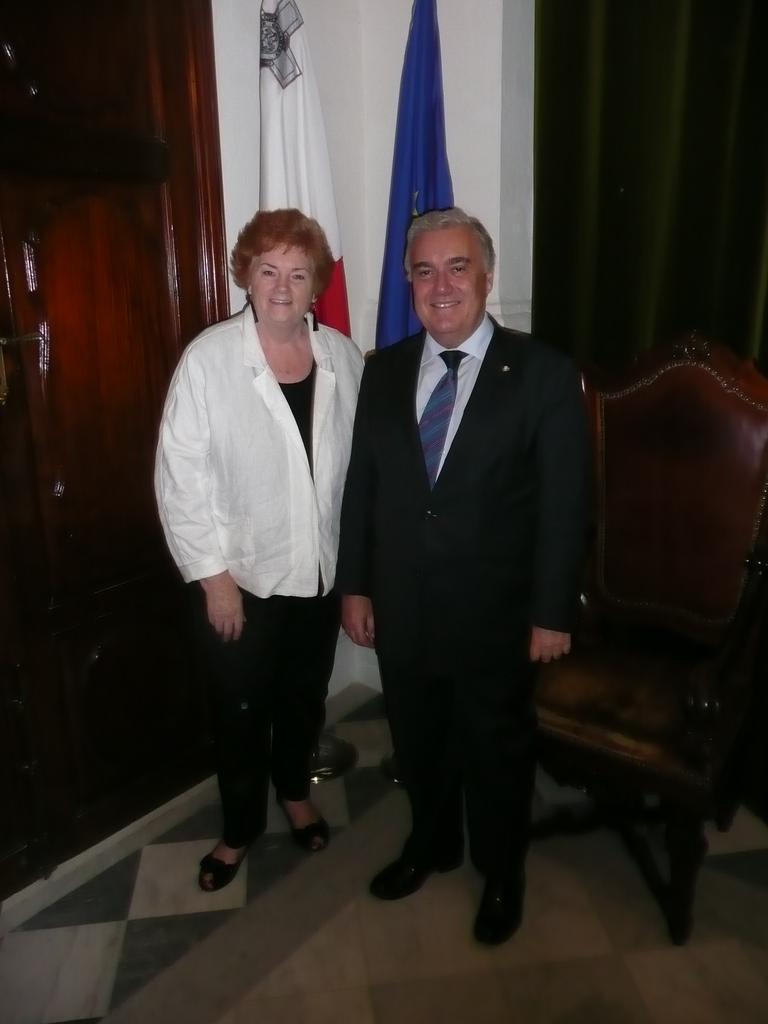Could you give a brief overview of what you see in this image? In this picture we can see man and woman standing and they are smiling and beside to them we have chairs, door and at back of them two flags. 